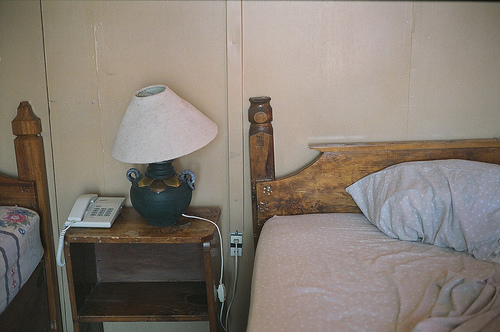<image>
Is the table in front of the wall? Yes. The table is positioned in front of the wall, appearing closer to the camera viewpoint. 